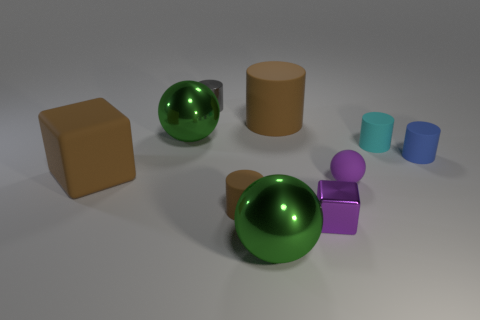Subtract all blue cylinders. How many cylinders are left? 4 Subtract all metallic cylinders. How many cylinders are left? 4 Subtract all purple cylinders. Subtract all green cubes. How many cylinders are left? 5 Subtract all blocks. How many objects are left? 8 Subtract 1 blue cylinders. How many objects are left? 9 Subtract all yellow matte spheres. Subtract all cyan rubber cylinders. How many objects are left? 9 Add 3 large brown rubber objects. How many large brown rubber objects are left? 5 Add 8 tiny cyan matte things. How many tiny cyan matte things exist? 9 